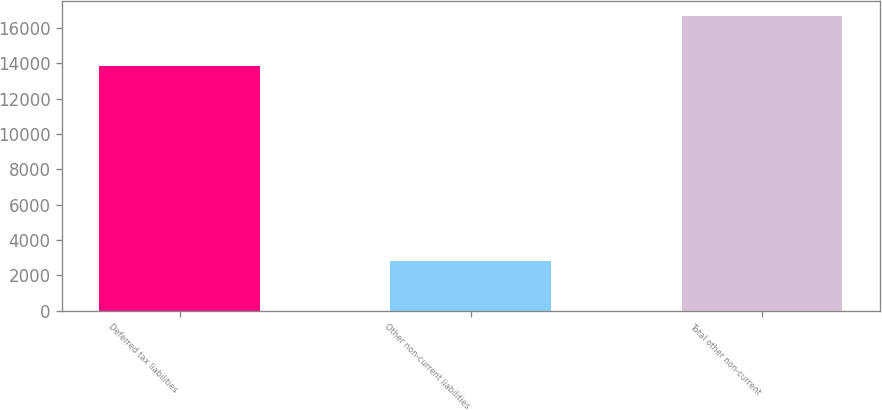Convert chart to OTSL. <chart><loc_0><loc_0><loc_500><loc_500><bar_chart><fcel>Deferred tax liabilities<fcel>Other non-current liabilities<fcel>Total other non-current<nl><fcel>13847<fcel>2817<fcel>16664<nl></chart> 